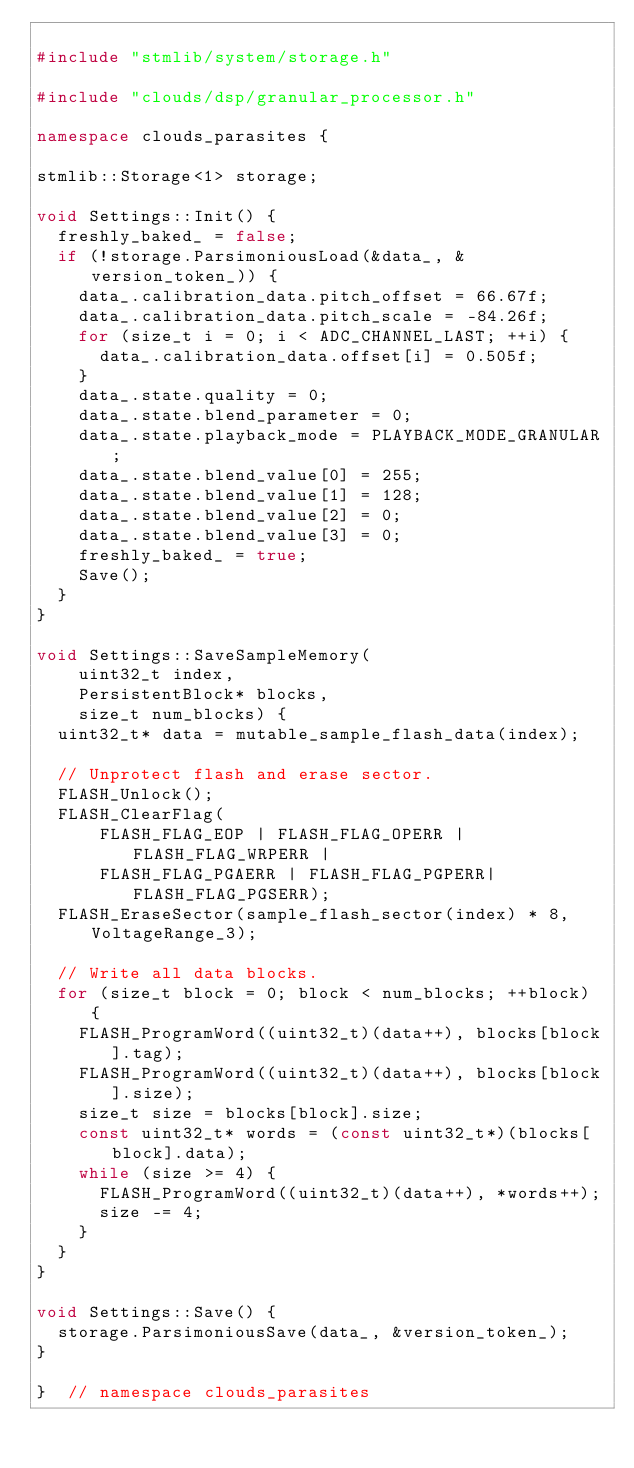Convert code to text. <code><loc_0><loc_0><loc_500><loc_500><_C++_>
#include "stmlib/system/storage.h"

#include "clouds/dsp/granular_processor.h"

namespace clouds_parasites {

stmlib::Storage<1> storage;

void Settings::Init() {
  freshly_baked_ = false;
  if (!storage.ParsimoniousLoad(&data_, &version_token_)) {
    data_.calibration_data.pitch_offset = 66.67f;
    data_.calibration_data.pitch_scale = -84.26f;
    for (size_t i = 0; i < ADC_CHANNEL_LAST; ++i) {
      data_.calibration_data.offset[i] = 0.505f;
    }
    data_.state.quality = 0;
    data_.state.blend_parameter = 0;
    data_.state.playback_mode = PLAYBACK_MODE_GRANULAR;
    data_.state.blend_value[0] = 255;
    data_.state.blend_value[1] = 128;
    data_.state.blend_value[2] = 0;
    data_.state.blend_value[3] = 0;
    freshly_baked_ = true;
    Save();
  }
}

void Settings::SaveSampleMemory(
    uint32_t index,
    PersistentBlock* blocks,
    size_t num_blocks) {
  uint32_t* data = mutable_sample_flash_data(index);
  
  // Unprotect flash and erase sector.
  FLASH_Unlock();
  FLASH_ClearFlag(
      FLASH_FLAG_EOP | FLASH_FLAG_OPERR | FLASH_FLAG_WRPERR | 
      FLASH_FLAG_PGAERR | FLASH_FLAG_PGPERR| FLASH_FLAG_PGSERR); 
  FLASH_EraseSector(sample_flash_sector(index) * 8, VoltageRange_3);
  
  // Write all data blocks.
  for (size_t block = 0; block < num_blocks; ++block) {
    FLASH_ProgramWord((uint32_t)(data++), blocks[block].tag);
    FLASH_ProgramWord((uint32_t)(data++), blocks[block].size);
    size_t size = blocks[block].size;
    const uint32_t* words = (const uint32_t*)(blocks[block].data);
    while (size >= 4) {
      FLASH_ProgramWord((uint32_t)(data++), *words++);
      size -= 4;
    }
  }
}

void Settings::Save() {
  storage.ParsimoniousSave(data_, &version_token_);
}

}  // namespace clouds_parasites
</code> 